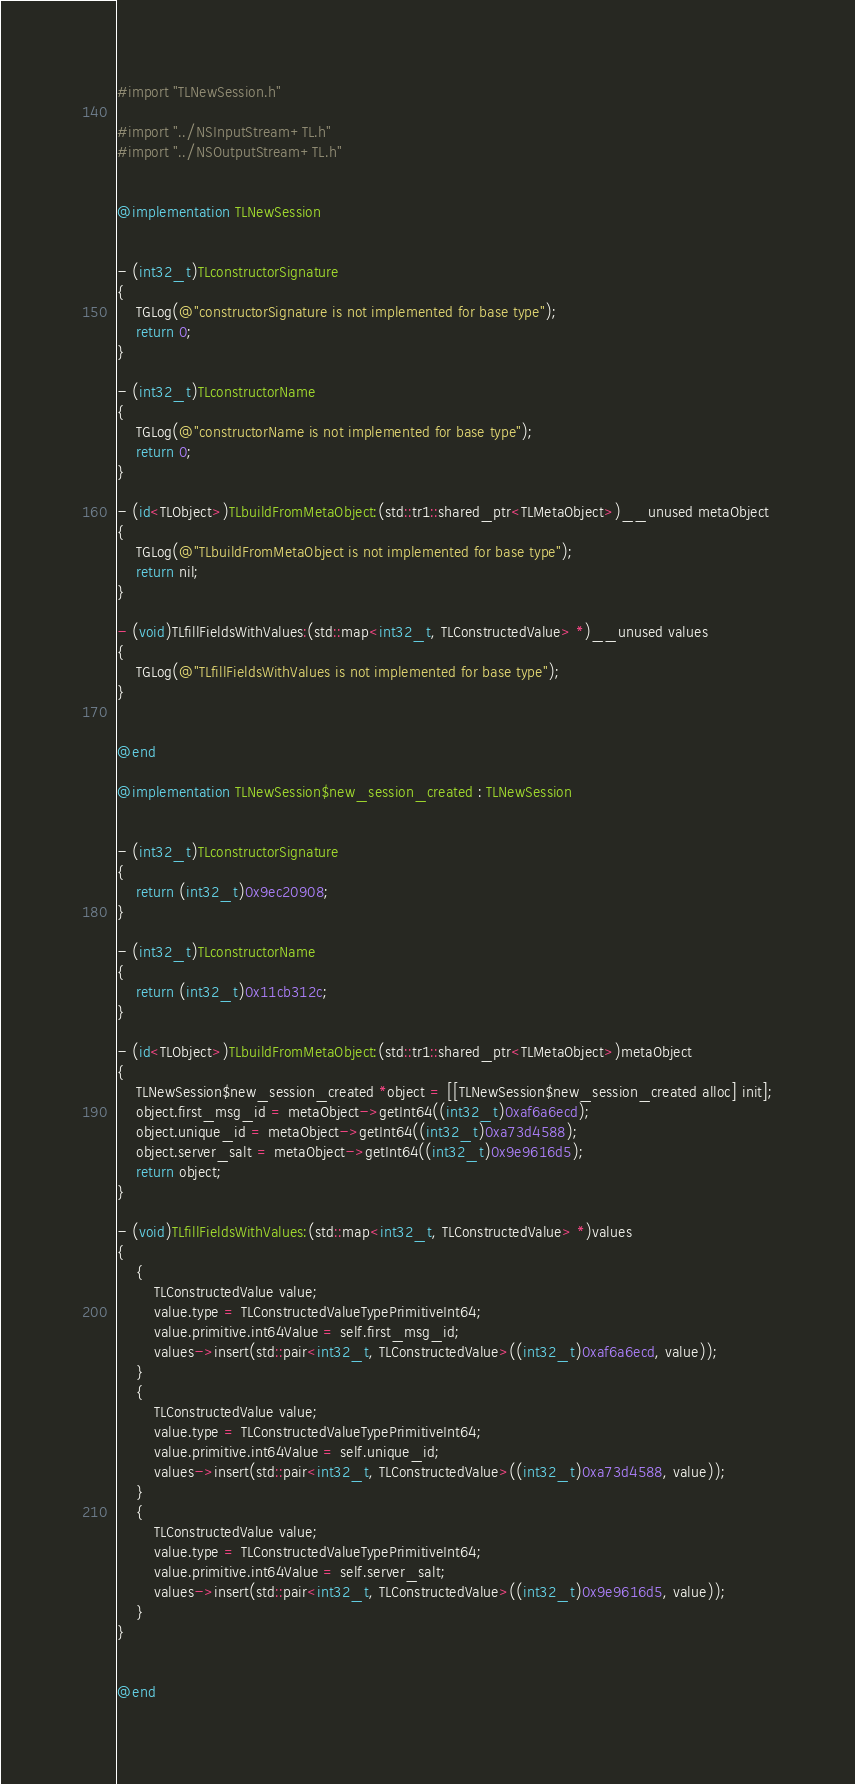Convert code to text. <code><loc_0><loc_0><loc_500><loc_500><_ObjectiveC_>#import "TLNewSession.h"

#import "../NSInputStream+TL.h"
#import "../NSOutputStream+TL.h"


@implementation TLNewSession


- (int32_t)TLconstructorSignature
{
    TGLog(@"constructorSignature is not implemented for base type");
    return 0;
}

- (int32_t)TLconstructorName
{
    TGLog(@"constructorName is not implemented for base type");
    return 0;
}

- (id<TLObject>)TLbuildFromMetaObject:(std::tr1::shared_ptr<TLMetaObject>)__unused metaObject
{
    TGLog(@"TLbuildFromMetaObject is not implemented for base type");
    return nil;
}

- (void)TLfillFieldsWithValues:(std::map<int32_t, TLConstructedValue> *)__unused values
{
    TGLog(@"TLfillFieldsWithValues is not implemented for base type");
}


@end

@implementation TLNewSession$new_session_created : TLNewSession


- (int32_t)TLconstructorSignature
{
    return (int32_t)0x9ec20908;
}

- (int32_t)TLconstructorName
{
    return (int32_t)0x11cb312c;
}

- (id<TLObject>)TLbuildFromMetaObject:(std::tr1::shared_ptr<TLMetaObject>)metaObject
{
    TLNewSession$new_session_created *object = [[TLNewSession$new_session_created alloc] init];
    object.first_msg_id = metaObject->getInt64((int32_t)0xaf6a6ecd);
    object.unique_id = metaObject->getInt64((int32_t)0xa73d4588);
    object.server_salt = metaObject->getInt64((int32_t)0x9e9616d5);
    return object;
}

- (void)TLfillFieldsWithValues:(std::map<int32_t, TLConstructedValue> *)values
{
    {
        TLConstructedValue value;
        value.type = TLConstructedValueTypePrimitiveInt64;
        value.primitive.int64Value = self.first_msg_id;
        values->insert(std::pair<int32_t, TLConstructedValue>((int32_t)0xaf6a6ecd, value));
    }
    {
        TLConstructedValue value;
        value.type = TLConstructedValueTypePrimitiveInt64;
        value.primitive.int64Value = self.unique_id;
        values->insert(std::pair<int32_t, TLConstructedValue>((int32_t)0xa73d4588, value));
    }
    {
        TLConstructedValue value;
        value.type = TLConstructedValueTypePrimitiveInt64;
        value.primitive.int64Value = self.server_salt;
        values->insert(std::pair<int32_t, TLConstructedValue>((int32_t)0x9e9616d5, value));
    }
}


@end

</code> 